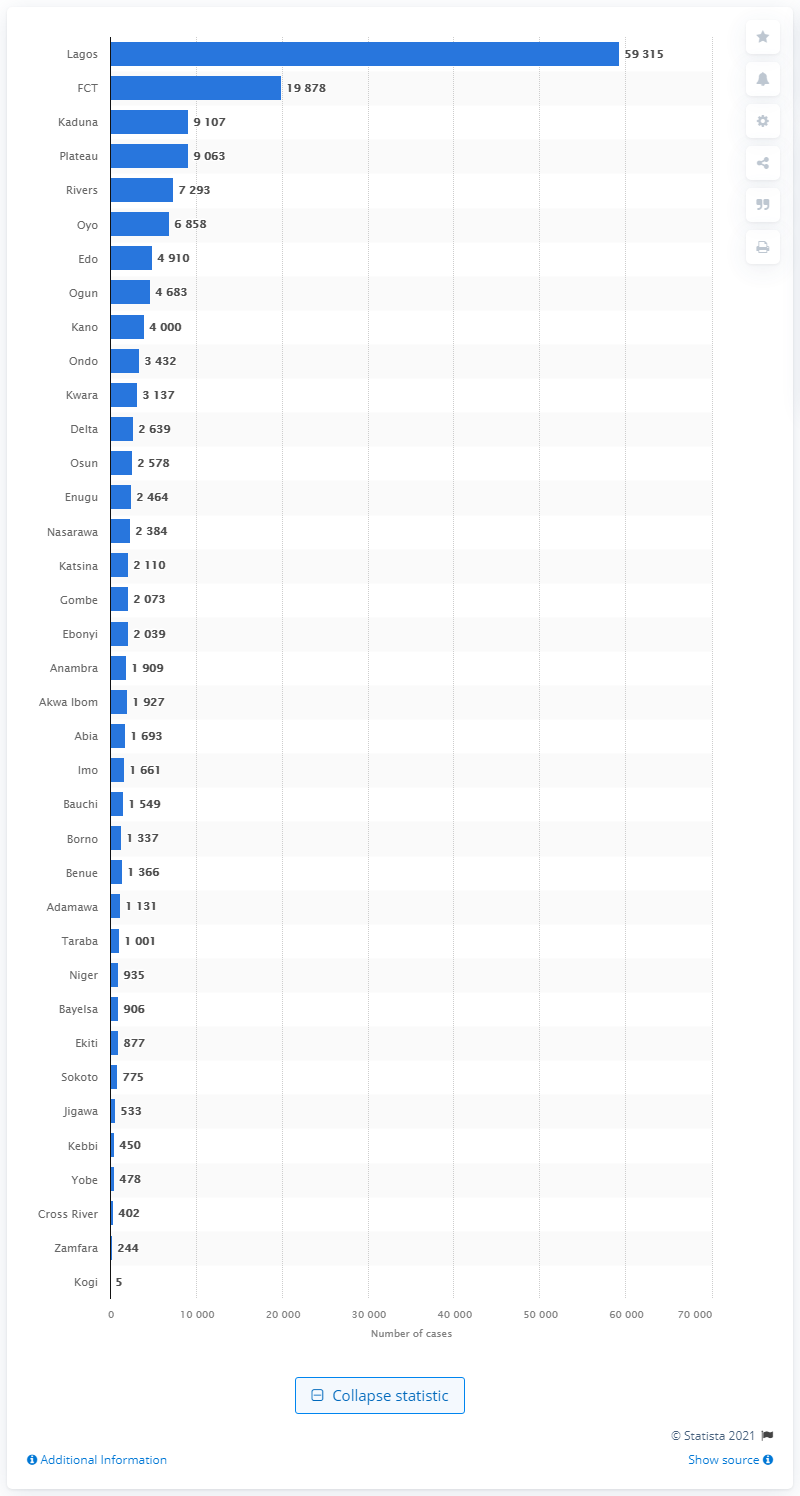Identify some key points in this picture. Lagos State in Nigeria had the highest number of confirmed cases of COVID-19. 